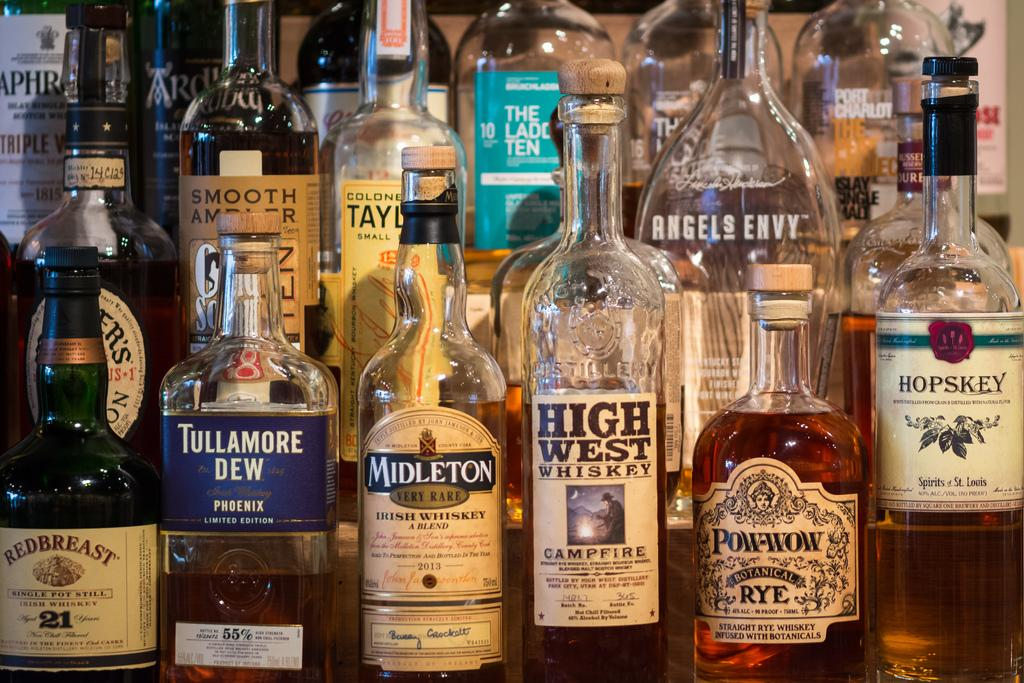<image>
Provide a brief description of the given image. Many bottles of liquor displayed, including Redbreast Irish Whiskey, Tullamore Dew, Midleton Irish Whiskey, High West Whiskey, and Pow-Wow Botanical Rye. 